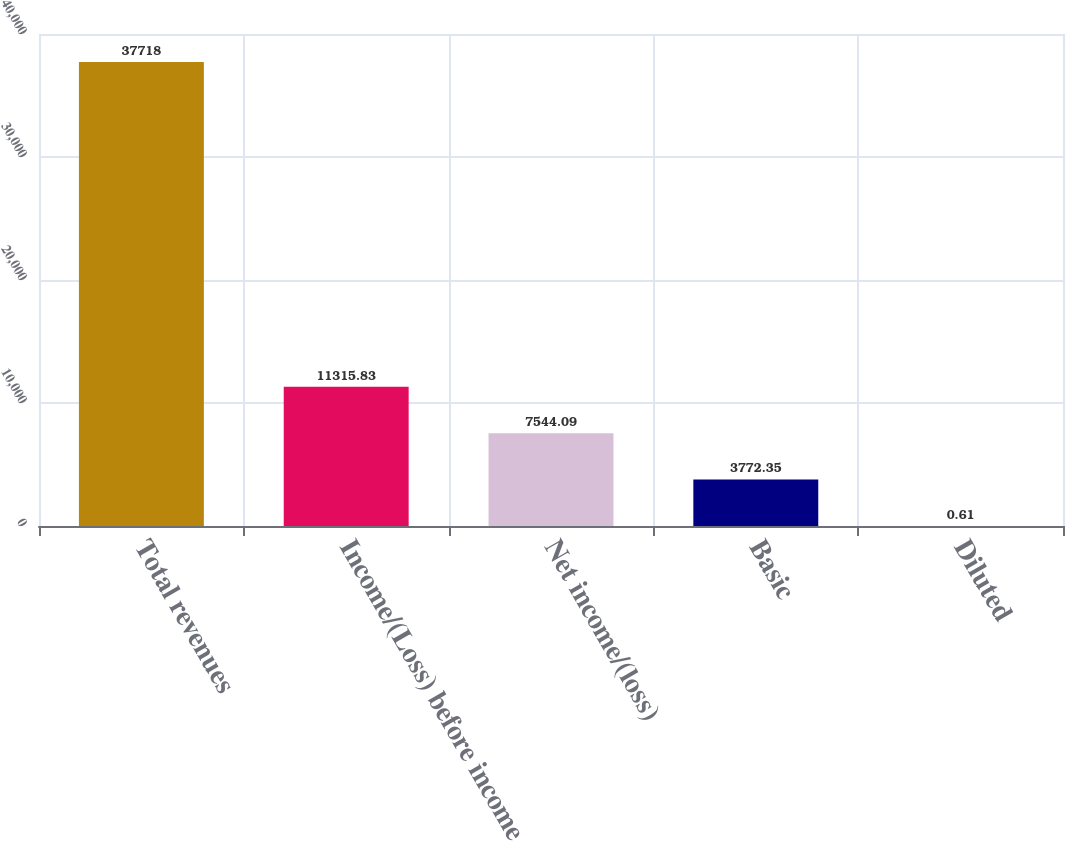Convert chart. <chart><loc_0><loc_0><loc_500><loc_500><bar_chart><fcel>Total revenues<fcel>Income/(Loss) before income<fcel>Net income/(loss)<fcel>Basic<fcel>Diluted<nl><fcel>37718<fcel>11315.8<fcel>7544.09<fcel>3772.35<fcel>0.61<nl></chart> 